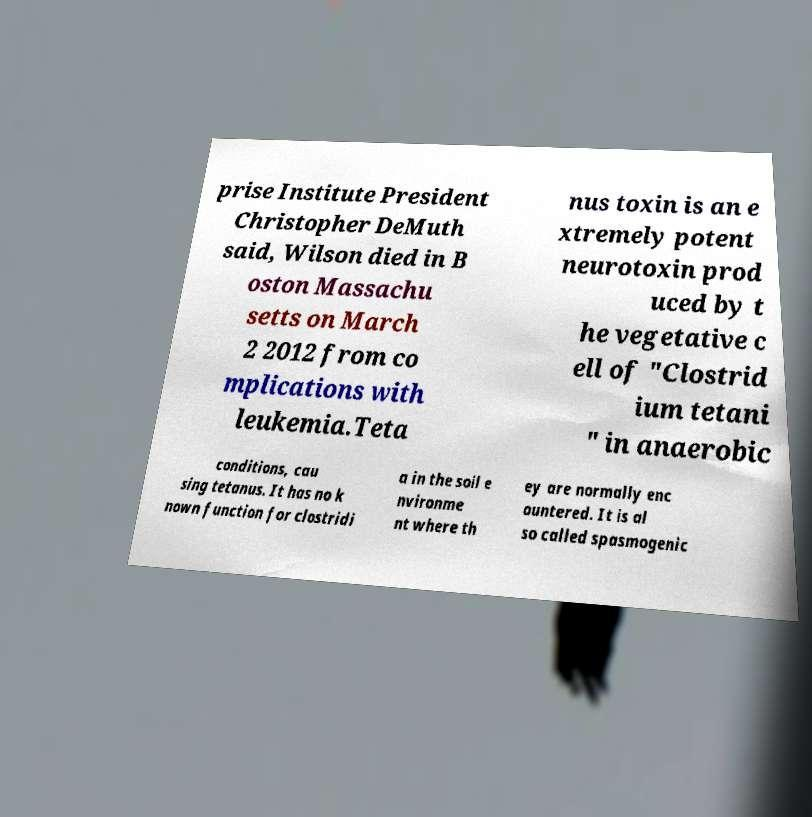Please identify and transcribe the text found in this image. prise Institute President Christopher DeMuth said, Wilson died in B oston Massachu setts on March 2 2012 from co mplications with leukemia.Teta nus toxin is an e xtremely potent neurotoxin prod uced by t he vegetative c ell of "Clostrid ium tetani " in anaerobic conditions, cau sing tetanus. It has no k nown function for clostridi a in the soil e nvironme nt where th ey are normally enc ountered. It is al so called spasmogenic 